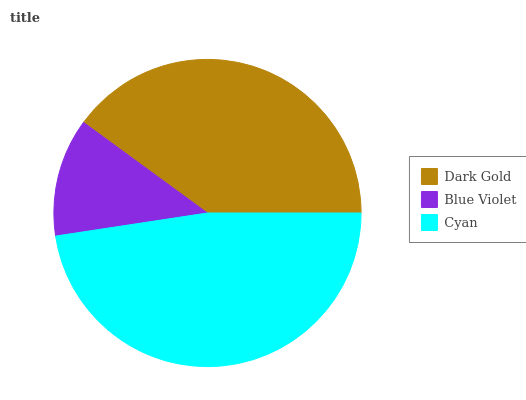Is Blue Violet the minimum?
Answer yes or no. Yes. Is Cyan the maximum?
Answer yes or no. Yes. Is Cyan the minimum?
Answer yes or no. No. Is Blue Violet the maximum?
Answer yes or no. No. Is Cyan greater than Blue Violet?
Answer yes or no. Yes. Is Blue Violet less than Cyan?
Answer yes or no. Yes. Is Blue Violet greater than Cyan?
Answer yes or no. No. Is Cyan less than Blue Violet?
Answer yes or no. No. Is Dark Gold the high median?
Answer yes or no. Yes. Is Dark Gold the low median?
Answer yes or no. Yes. Is Blue Violet the high median?
Answer yes or no. No. Is Cyan the low median?
Answer yes or no. No. 